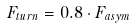<formula> <loc_0><loc_0><loc_500><loc_500>F _ { t u r n } = 0 . 8 \cdot F _ { a s y m }</formula> 